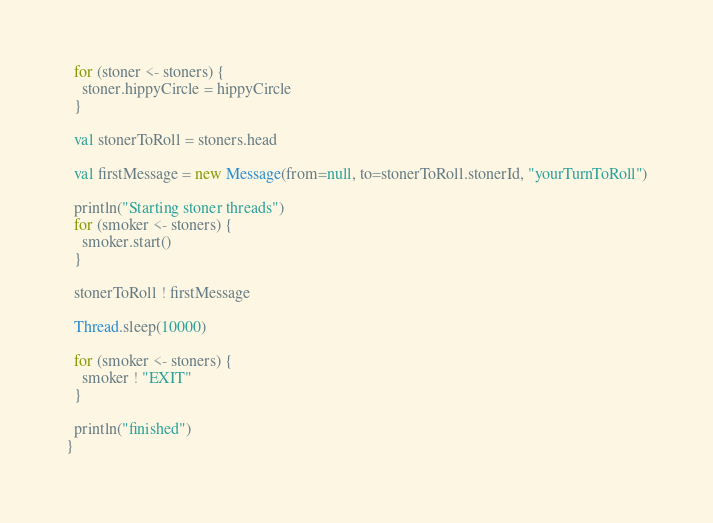Convert code to text. <code><loc_0><loc_0><loc_500><loc_500><_Scala_>  for (stoner <- stoners) {
    stoner.hippyCircle = hippyCircle
  }

  val stonerToRoll = stoners.head
  
  val firstMessage = new Message(from=null, to=stonerToRoll.stonerId, "yourTurnToRoll")

  println("Starting stoner threads")
  for (smoker <- stoners) {
    smoker.start()
  }

  stonerToRoll ! firstMessage

  Thread.sleep(10000)

  for (smoker <- stoners) {
    smoker ! "EXIT"
  }

  println("finished")
}</code> 